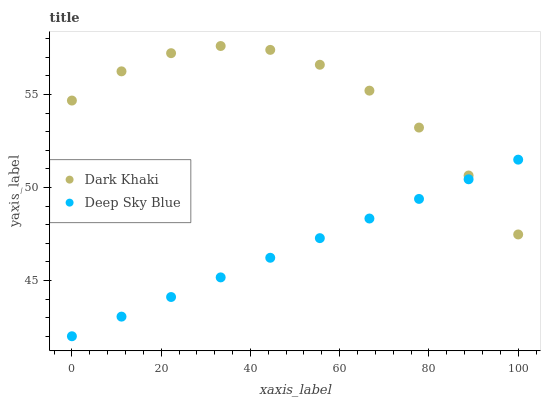Does Deep Sky Blue have the minimum area under the curve?
Answer yes or no. Yes. Does Dark Khaki have the maximum area under the curve?
Answer yes or no. Yes. Does Deep Sky Blue have the maximum area under the curve?
Answer yes or no. No. Is Deep Sky Blue the smoothest?
Answer yes or no. Yes. Is Dark Khaki the roughest?
Answer yes or no. Yes. Is Deep Sky Blue the roughest?
Answer yes or no. No. Does Deep Sky Blue have the lowest value?
Answer yes or no. Yes. Does Dark Khaki have the highest value?
Answer yes or no. Yes. Does Deep Sky Blue have the highest value?
Answer yes or no. No. Does Dark Khaki intersect Deep Sky Blue?
Answer yes or no. Yes. Is Dark Khaki less than Deep Sky Blue?
Answer yes or no. No. Is Dark Khaki greater than Deep Sky Blue?
Answer yes or no. No. 